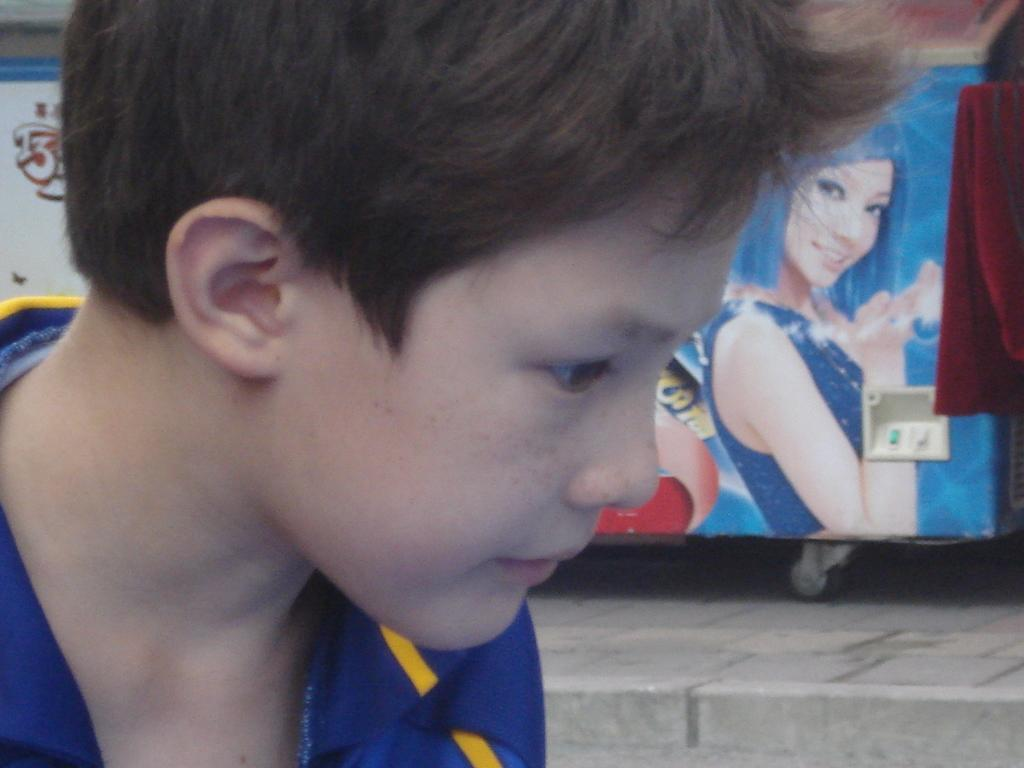What is the main subject of the image? The main subject of the image is a kid's face. What else can be seen in the background of the image? There is a poster on a freezer in the image. What type of juice is the kid drinking in the image? There is no juice present in the image; it only features a kid's face and a poster on a freezer. How far away is the distance between the kid's face and the poster on the freezer? The provided facts do not give any information about the distance between the kid's face and the poster on the freezer. --- 